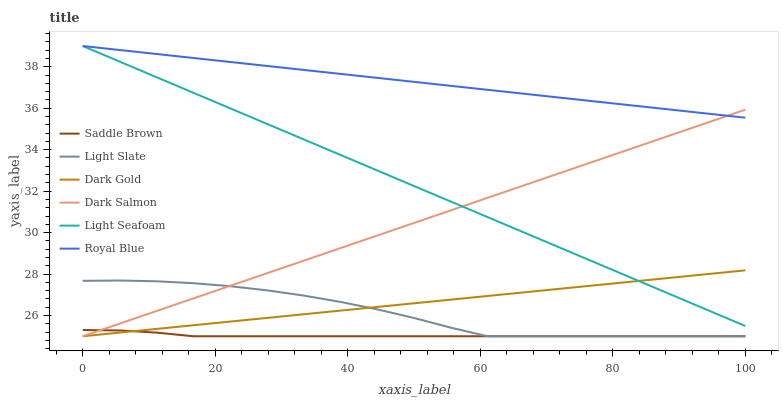Does Light Slate have the minimum area under the curve?
Answer yes or no. No. Does Light Slate have the maximum area under the curve?
Answer yes or no. No. Is Dark Salmon the smoothest?
Answer yes or no. No. Is Dark Salmon the roughest?
Answer yes or no. No. Does Royal Blue have the lowest value?
Answer yes or no. No. Does Light Slate have the highest value?
Answer yes or no. No. Is Light Slate less than Light Seafoam?
Answer yes or no. Yes. Is Light Seafoam greater than Saddle Brown?
Answer yes or no. Yes. Does Light Slate intersect Light Seafoam?
Answer yes or no. No. 